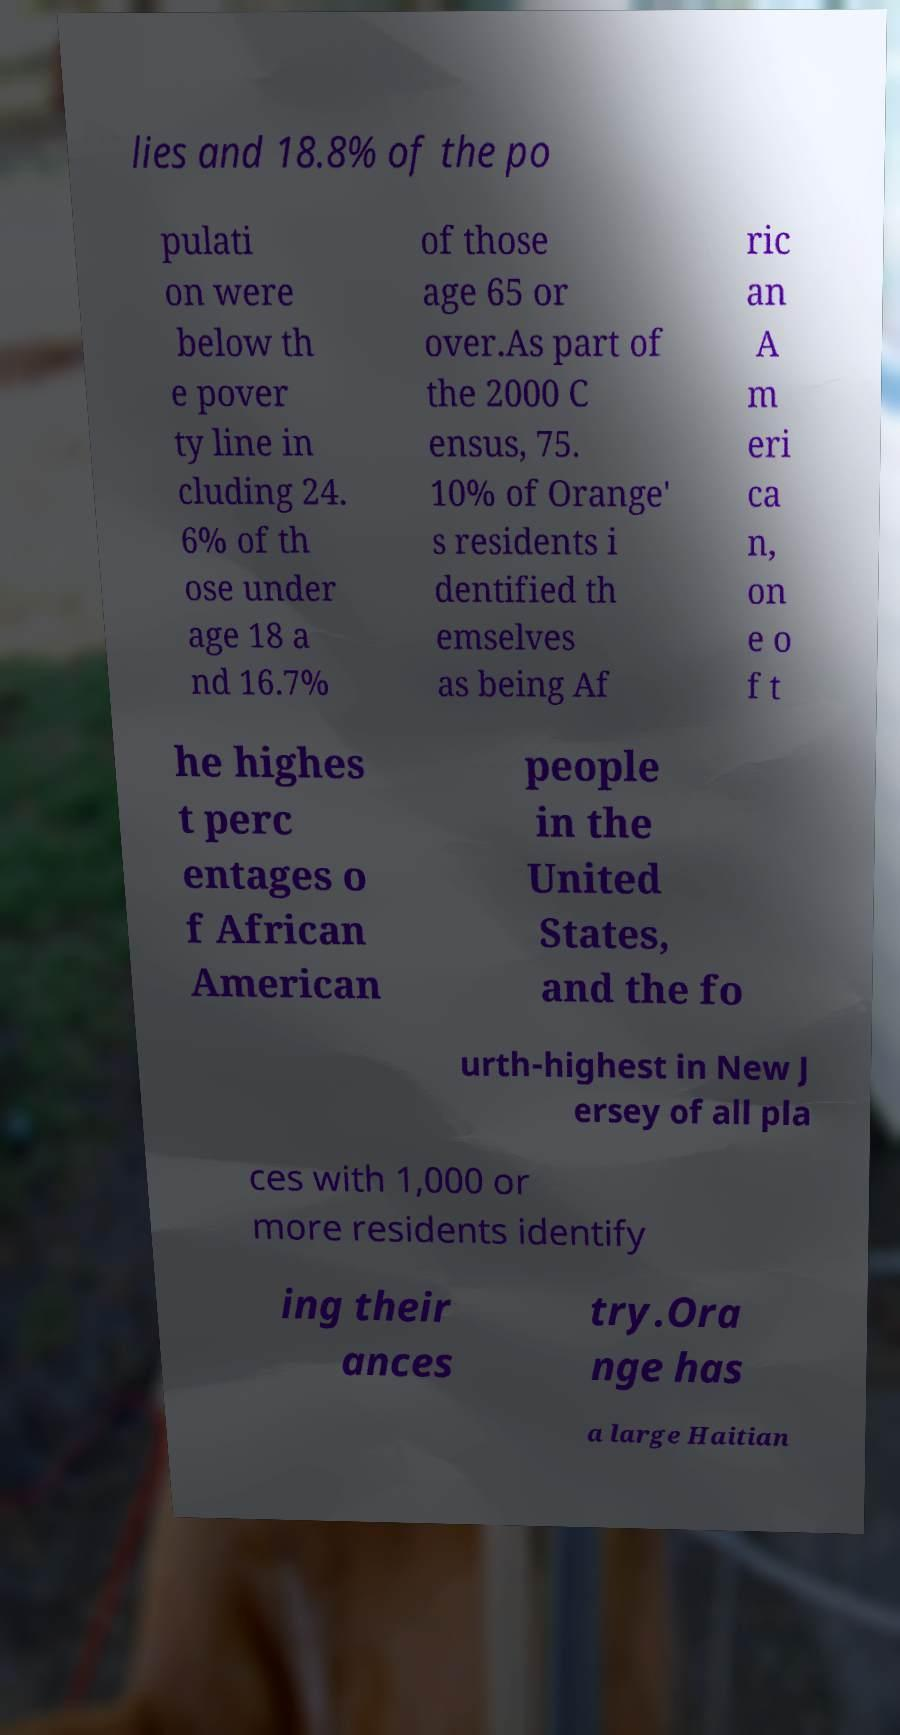Please read and relay the text visible in this image. What does it say? lies and 18.8% of the po pulati on were below th e pover ty line in cluding 24. 6% of th ose under age 18 a nd 16.7% of those age 65 or over.As part of the 2000 C ensus, 75. 10% of Orange' s residents i dentified th emselves as being Af ric an A m eri ca n, on e o f t he highes t perc entages o f African American people in the United States, and the fo urth-highest in New J ersey of all pla ces with 1,000 or more residents identify ing their ances try.Ora nge has a large Haitian 